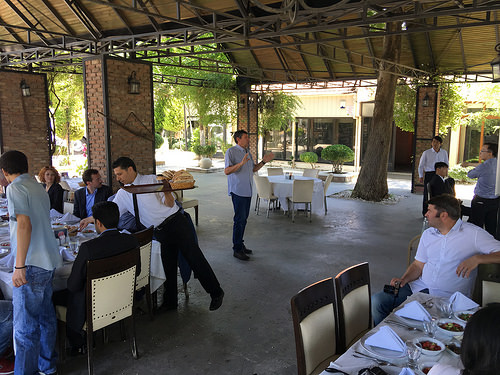<image>
Is there a plate on the man? No. The plate is not positioned on the man. They may be near each other, but the plate is not supported by or resting on top of the man. 